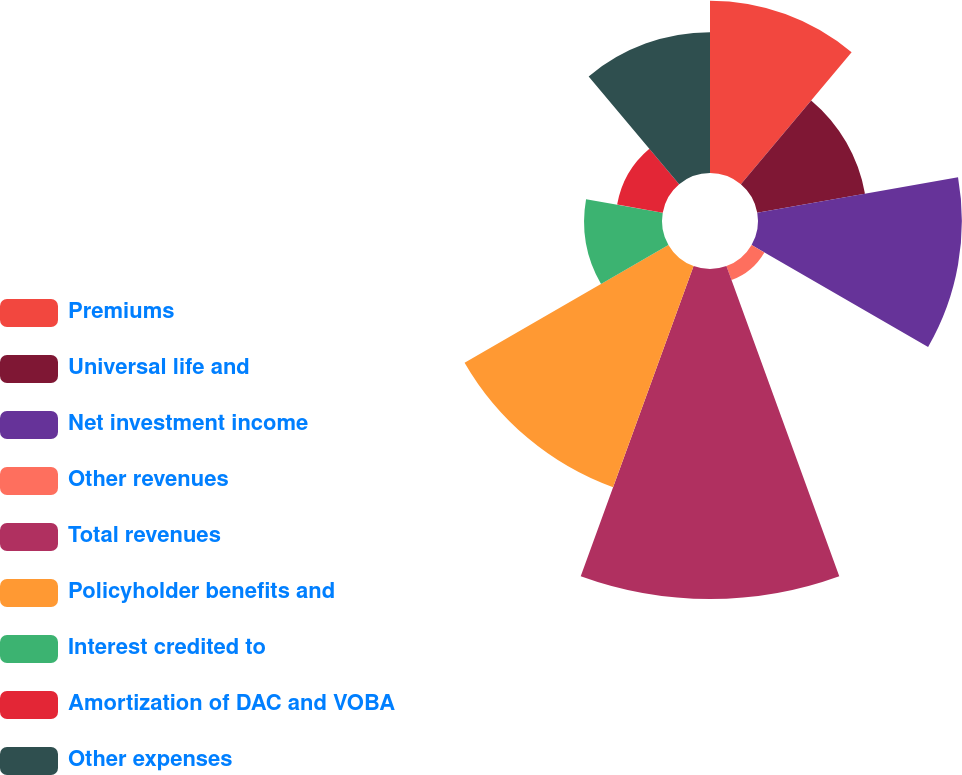Convert chart. <chart><loc_0><loc_0><loc_500><loc_500><pie_chart><fcel>Premiums<fcel>Universal life and<fcel>Net investment income<fcel>Other revenues<fcel>Total revenues<fcel>Policyholder benefits and<fcel>Interest credited to<fcel>Amortization of DAC and VOBA<fcel>Other expenses<nl><fcel>12.95%<fcel>8.22%<fcel>15.32%<fcel>1.11%<fcel>24.8%<fcel>17.69%<fcel>5.85%<fcel>3.48%<fcel>10.58%<nl></chart> 